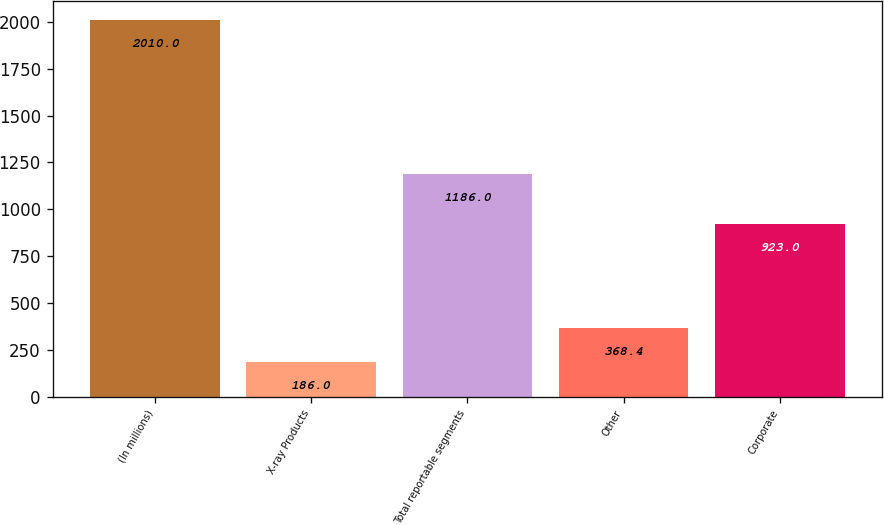<chart> <loc_0><loc_0><loc_500><loc_500><bar_chart><fcel>(In millions)<fcel>X-ray Products<fcel>Total reportable segments<fcel>Other<fcel>Corporate<nl><fcel>2010<fcel>186<fcel>1186<fcel>368.4<fcel>923<nl></chart> 